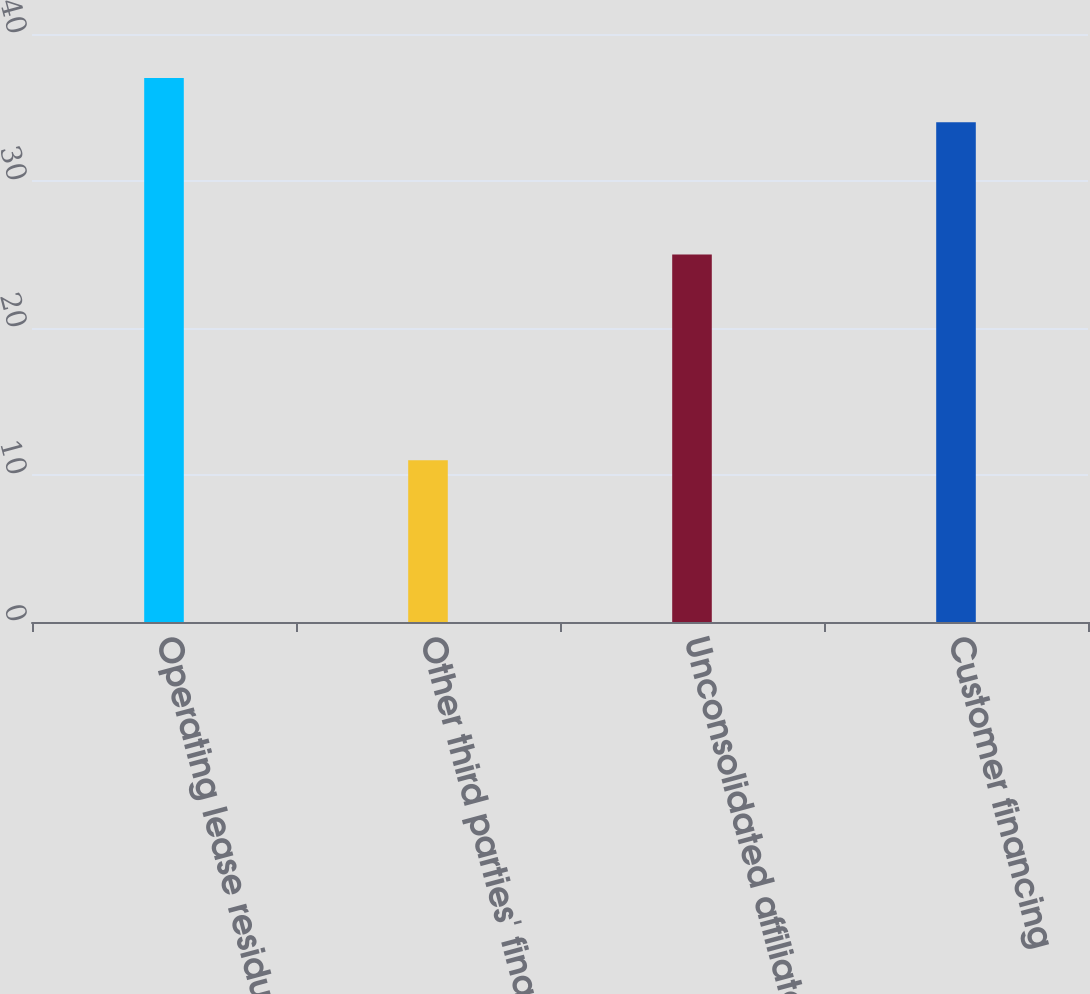Convert chart. <chart><loc_0><loc_0><loc_500><loc_500><bar_chart><fcel>Operating lease residual<fcel>Other third parties' financing<fcel>Unconsolidated affiliates'<fcel>Customer financing<nl><fcel>37<fcel>11<fcel>25<fcel>34<nl></chart> 